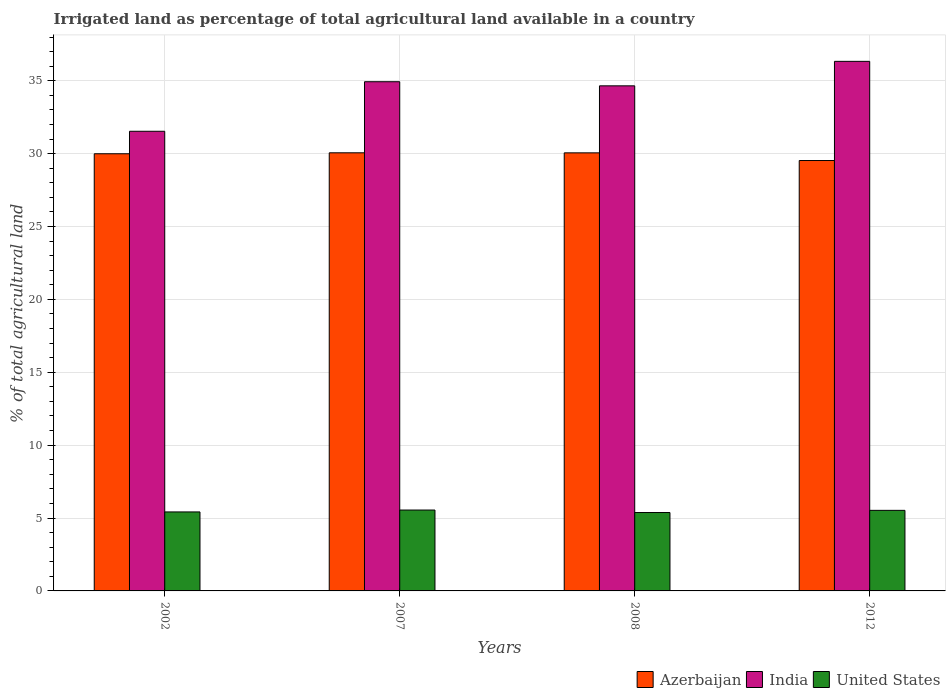How many groups of bars are there?
Keep it short and to the point. 4. Are the number of bars per tick equal to the number of legend labels?
Provide a succinct answer. Yes. How many bars are there on the 2nd tick from the left?
Keep it short and to the point. 3. In how many cases, is the number of bars for a given year not equal to the number of legend labels?
Make the answer very short. 0. What is the percentage of irrigated land in Azerbaijan in 2002?
Offer a very short reply. 29.99. Across all years, what is the maximum percentage of irrigated land in Azerbaijan?
Give a very brief answer. 30.06. Across all years, what is the minimum percentage of irrigated land in India?
Your answer should be very brief. 31.53. In which year was the percentage of irrigated land in India maximum?
Your answer should be compact. 2012. In which year was the percentage of irrigated land in Azerbaijan minimum?
Provide a succinct answer. 2012. What is the total percentage of irrigated land in United States in the graph?
Keep it short and to the point. 21.87. What is the difference between the percentage of irrigated land in India in 2008 and that in 2012?
Make the answer very short. -1.68. What is the difference between the percentage of irrigated land in United States in 2007 and the percentage of irrigated land in Azerbaijan in 2002?
Provide a succinct answer. -24.44. What is the average percentage of irrigated land in Azerbaijan per year?
Your answer should be very brief. 29.91. In the year 2007, what is the difference between the percentage of irrigated land in United States and percentage of irrigated land in India?
Offer a very short reply. -29.38. In how many years, is the percentage of irrigated land in Azerbaijan greater than 17 %?
Provide a short and direct response. 4. What is the ratio of the percentage of irrigated land in United States in 2002 to that in 2012?
Your response must be concise. 0.98. Is the percentage of irrigated land in United States in 2002 less than that in 2012?
Offer a very short reply. Yes. Is the difference between the percentage of irrigated land in United States in 2008 and 2012 greater than the difference between the percentage of irrigated land in India in 2008 and 2012?
Ensure brevity in your answer.  Yes. What is the difference between the highest and the second highest percentage of irrigated land in Azerbaijan?
Ensure brevity in your answer.  0. What is the difference between the highest and the lowest percentage of irrigated land in India?
Offer a very short reply. 4.8. Is the sum of the percentage of irrigated land in Azerbaijan in 2002 and 2008 greater than the maximum percentage of irrigated land in United States across all years?
Make the answer very short. Yes. What does the 2nd bar from the right in 2012 represents?
Keep it short and to the point. India. How many years are there in the graph?
Give a very brief answer. 4. Are the values on the major ticks of Y-axis written in scientific E-notation?
Give a very brief answer. No. Does the graph contain any zero values?
Offer a very short reply. No. Does the graph contain grids?
Give a very brief answer. Yes. How many legend labels are there?
Offer a very short reply. 3. What is the title of the graph?
Provide a short and direct response. Irrigated land as percentage of total agricultural land available in a country. Does "Botswana" appear as one of the legend labels in the graph?
Provide a short and direct response. No. What is the label or title of the X-axis?
Ensure brevity in your answer.  Years. What is the label or title of the Y-axis?
Keep it short and to the point. % of total agricultural land. What is the % of total agricultural land of Azerbaijan in 2002?
Provide a short and direct response. 29.99. What is the % of total agricultural land of India in 2002?
Keep it short and to the point. 31.53. What is the % of total agricultural land in United States in 2002?
Offer a very short reply. 5.42. What is the % of total agricultural land of Azerbaijan in 2007?
Offer a very short reply. 30.06. What is the % of total agricultural land in India in 2007?
Provide a succinct answer. 34.93. What is the % of total agricultural land in United States in 2007?
Offer a terse response. 5.55. What is the % of total agricultural land in Azerbaijan in 2008?
Provide a succinct answer. 30.05. What is the % of total agricultural land of India in 2008?
Keep it short and to the point. 34.65. What is the % of total agricultural land in United States in 2008?
Your response must be concise. 5.38. What is the % of total agricultural land in Azerbaijan in 2012?
Offer a very short reply. 29.53. What is the % of total agricultural land in India in 2012?
Your answer should be compact. 36.33. What is the % of total agricultural land of United States in 2012?
Your response must be concise. 5.53. Across all years, what is the maximum % of total agricultural land of Azerbaijan?
Make the answer very short. 30.06. Across all years, what is the maximum % of total agricultural land of India?
Your answer should be very brief. 36.33. Across all years, what is the maximum % of total agricultural land of United States?
Offer a very short reply. 5.55. Across all years, what is the minimum % of total agricultural land in Azerbaijan?
Your answer should be very brief. 29.53. Across all years, what is the minimum % of total agricultural land of India?
Provide a succinct answer. 31.53. Across all years, what is the minimum % of total agricultural land of United States?
Provide a short and direct response. 5.38. What is the total % of total agricultural land in Azerbaijan in the graph?
Provide a succinct answer. 119.62. What is the total % of total agricultural land in India in the graph?
Ensure brevity in your answer.  137.44. What is the total % of total agricultural land in United States in the graph?
Make the answer very short. 21.87. What is the difference between the % of total agricultural land in Azerbaijan in 2002 and that in 2007?
Make the answer very short. -0.07. What is the difference between the % of total agricultural land in India in 2002 and that in 2007?
Offer a very short reply. -3.4. What is the difference between the % of total agricultural land of United States in 2002 and that in 2007?
Provide a short and direct response. -0.13. What is the difference between the % of total agricultural land in Azerbaijan in 2002 and that in 2008?
Offer a very short reply. -0.06. What is the difference between the % of total agricultural land of India in 2002 and that in 2008?
Keep it short and to the point. -3.12. What is the difference between the % of total agricultural land of United States in 2002 and that in 2008?
Your response must be concise. 0.04. What is the difference between the % of total agricultural land of Azerbaijan in 2002 and that in 2012?
Make the answer very short. 0.46. What is the difference between the % of total agricultural land of India in 2002 and that in 2012?
Provide a short and direct response. -4.8. What is the difference between the % of total agricultural land in United States in 2002 and that in 2012?
Provide a short and direct response. -0.11. What is the difference between the % of total agricultural land of Azerbaijan in 2007 and that in 2008?
Provide a short and direct response. 0. What is the difference between the % of total agricultural land in India in 2007 and that in 2008?
Offer a very short reply. 0.28. What is the difference between the % of total agricultural land of United States in 2007 and that in 2008?
Your answer should be compact. 0.17. What is the difference between the % of total agricultural land in Azerbaijan in 2007 and that in 2012?
Offer a terse response. 0.53. What is the difference between the % of total agricultural land of India in 2007 and that in 2012?
Keep it short and to the point. -1.4. What is the difference between the % of total agricultural land of United States in 2007 and that in 2012?
Keep it short and to the point. 0.02. What is the difference between the % of total agricultural land in Azerbaijan in 2008 and that in 2012?
Offer a very short reply. 0.53. What is the difference between the % of total agricultural land of India in 2008 and that in 2012?
Ensure brevity in your answer.  -1.68. What is the difference between the % of total agricultural land in United States in 2008 and that in 2012?
Your answer should be compact. -0.15. What is the difference between the % of total agricultural land of Azerbaijan in 2002 and the % of total agricultural land of India in 2007?
Give a very brief answer. -4.94. What is the difference between the % of total agricultural land in Azerbaijan in 2002 and the % of total agricultural land in United States in 2007?
Offer a very short reply. 24.44. What is the difference between the % of total agricultural land of India in 2002 and the % of total agricultural land of United States in 2007?
Provide a short and direct response. 25.98. What is the difference between the % of total agricultural land in Azerbaijan in 2002 and the % of total agricultural land in India in 2008?
Your answer should be compact. -4.66. What is the difference between the % of total agricultural land of Azerbaijan in 2002 and the % of total agricultural land of United States in 2008?
Give a very brief answer. 24.61. What is the difference between the % of total agricultural land of India in 2002 and the % of total agricultural land of United States in 2008?
Offer a very short reply. 26.15. What is the difference between the % of total agricultural land in Azerbaijan in 2002 and the % of total agricultural land in India in 2012?
Give a very brief answer. -6.34. What is the difference between the % of total agricultural land of Azerbaijan in 2002 and the % of total agricultural land of United States in 2012?
Offer a very short reply. 24.46. What is the difference between the % of total agricultural land in India in 2002 and the % of total agricultural land in United States in 2012?
Make the answer very short. 26.01. What is the difference between the % of total agricultural land of Azerbaijan in 2007 and the % of total agricultural land of India in 2008?
Your answer should be compact. -4.59. What is the difference between the % of total agricultural land of Azerbaijan in 2007 and the % of total agricultural land of United States in 2008?
Offer a terse response. 24.68. What is the difference between the % of total agricultural land in India in 2007 and the % of total agricultural land in United States in 2008?
Provide a short and direct response. 29.55. What is the difference between the % of total agricultural land of Azerbaijan in 2007 and the % of total agricultural land of India in 2012?
Provide a short and direct response. -6.27. What is the difference between the % of total agricultural land of Azerbaijan in 2007 and the % of total agricultural land of United States in 2012?
Ensure brevity in your answer.  24.53. What is the difference between the % of total agricultural land of India in 2007 and the % of total agricultural land of United States in 2012?
Keep it short and to the point. 29.4. What is the difference between the % of total agricultural land of Azerbaijan in 2008 and the % of total agricultural land of India in 2012?
Your response must be concise. -6.28. What is the difference between the % of total agricultural land of Azerbaijan in 2008 and the % of total agricultural land of United States in 2012?
Keep it short and to the point. 24.53. What is the difference between the % of total agricultural land in India in 2008 and the % of total agricultural land in United States in 2012?
Keep it short and to the point. 29.12. What is the average % of total agricultural land in Azerbaijan per year?
Give a very brief answer. 29.91. What is the average % of total agricultural land in India per year?
Your answer should be very brief. 34.36. What is the average % of total agricultural land in United States per year?
Your answer should be compact. 5.47. In the year 2002, what is the difference between the % of total agricultural land in Azerbaijan and % of total agricultural land in India?
Keep it short and to the point. -1.54. In the year 2002, what is the difference between the % of total agricultural land in Azerbaijan and % of total agricultural land in United States?
Your response must be concise. 24.57. In the year 2002, what is the difference between the % of total agricultural land in India and % of total agricultural land in United States?
Your answer should be very brief. 26.11. In the year 2007, what is the difference between the % of total agricultural land of Azerbaijan and % of total agricultural land of India?
Your response must be concise. -4.88. In the year 2007, what is the difference between the % of total agricultural land of Azerbaijan and % of total agricultural land of United States?
Give a very brief answer. 24.51. In the year 2007, what is the difference between the % of total agricultural land of India and % of total agricultural land of United States?
Provide a short and direct response. 29.38. In the year 2008, what is the difference between the % of total agricultural land in Azerbaijan and % of total agricultural land in India?
Your answer should be very brief. -4.6. In the year 2008, what is the difference between the % of total agricultural land of Azerbaijan and % of total agricultural land of United States?
Give a very brief answer. 24.67. In the year 2008, what is the difference between the % of total agricultural land in India and % of total agricultural land in United States?
Offer a very short reply. 29.27. In the year 2012, what is the difference between the % of total agricultural land of Azerbaijan and % of total agricultural land of India?
Give a very brief answer. -6.8. In the year 2012, what is the difference between the % of total agricultural land in Azerbaijan and % of total agricultural land in United States?
Provide a short and direct response. 24. In the year 2012, what is the difference between the % of total agricultural land of India and % of total agricultural land of United States?
Ensure brevity in your answer.  30.8. What is the ratio of the % of total agricultural land of Azerbaijan in 2002 to that in 2007?
Offer a very short reply. 1. What is the ratio of the % of total agricultural land of India in 2002 to that in 2007?
Keep it short and to the point. 0.9. What is the ratio of the % of total agricultural land in United States in 2002 to that in 2007?
Provide a succinct answer. 0.98. What is the ratio of the % of total agricultural land of Azerbaijan in 2002 to that in 2008?
Offer a terse response. 1. What is the ratio of the % of total agricultural land of India in 2002 to that in 2008?
Make the answer very short. 0.91. What is the ratio of the % of total agricultural land of United States in 2002 to that in 2008?
Provide a succinct answer. 1.01. What is the ratio of the % of total agricultural land in Azerbaijan in 2002 to that in 2012?
Provide a short and direct response. 1.02. What is the ratio of the % of total agricultural land in India in 2002 to that in 2012?
Keep it short and to the point. 0.87. What is the ratio of the % of total agricultural land of United States in 2002 to that in 2012?
Keep it short and to the point. 0.98. What is the ratio of the % of total agricultural land of United States in 2007 to that in 2008?
Ensure brevity in your answer.  1.03. What is the ratio of the % of total agricultural land in Azerbaijan in 2007 to that in 2012?
Make the answer very short. 1.02. What is the ratio of the % of total agricultural land of India in 2007 to that in 2012?
Provide a short and direct response. 0.96. What is the ratio of the % of total agricultural land in Azerbaijan in 2008 to that in 2012?
Give a very brief answer. 1.02. What is the ratio of the % of total agricultural land in India in 2008 to that in 2012?
Keep it short and to the point. 0.95. What is the ratio of the % of total agricultural land in United States in 2008 to that in 2012?
Offer a terse response. 0.97. What is the difference between the highest and the second highest % of total agricultural land of Azerbaijan?
Your answer should be compact. 0. What is the difference between the highest and the second highest % of total agricultural land of India?
Your response must be concise. 1.4. What is the difference between the highest and the second highest % of total agricultural land in United States?
Offer a terse response. 0.02. What is the difference between the highest and the lowest % of total agricultural land in Azerbaijan?
Your answer should be compact. 0.53. What is the difference between the highest and the lowest % of total agricultural land in India?
Give a very brief answer. 4.8. What is the difference between the highest and the lowest % of total agricultural land in United States?
Provide a succinct answer. 0.17. 